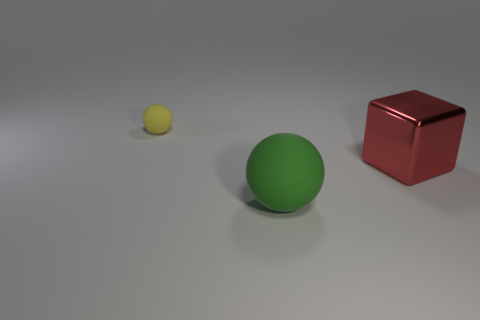Is there any other thing that is made of the same material as the big block?
Give a very brief answer. No. There is a metal object; how many tiny yellow things are left of it?
Your response must be concise. 1. Are any red shiny things visible?
Ensure brevity in your answer.  Yes. There is a rubber ball that is behind the object in front of the thing that is to the right of the big green object; what color is it?
Ensure brevity in your answer.  Yellow. Are there any green matte balls on the right side of the large thing in front of the red shiny block?
Your answer should be compact. No. There is a matte ball that is on the right side of the small thing; does it have the same color as the ball to the left of the green matte sphere?
Ensure brevity in your answer.  No. What number of other red metal blocks are the same size as the block?
Provide a short and direct response. 0. There is a rubber sphere that is in front of the red metallic object; is its size the same as the tiny object?
Offer a very short reply. No. The big red thing is what shape?
Keep it short and to the point. Cube. Is the ball that is in front of the metallic thing made of the same material as the red thing?
Offer a very short reply. No. 